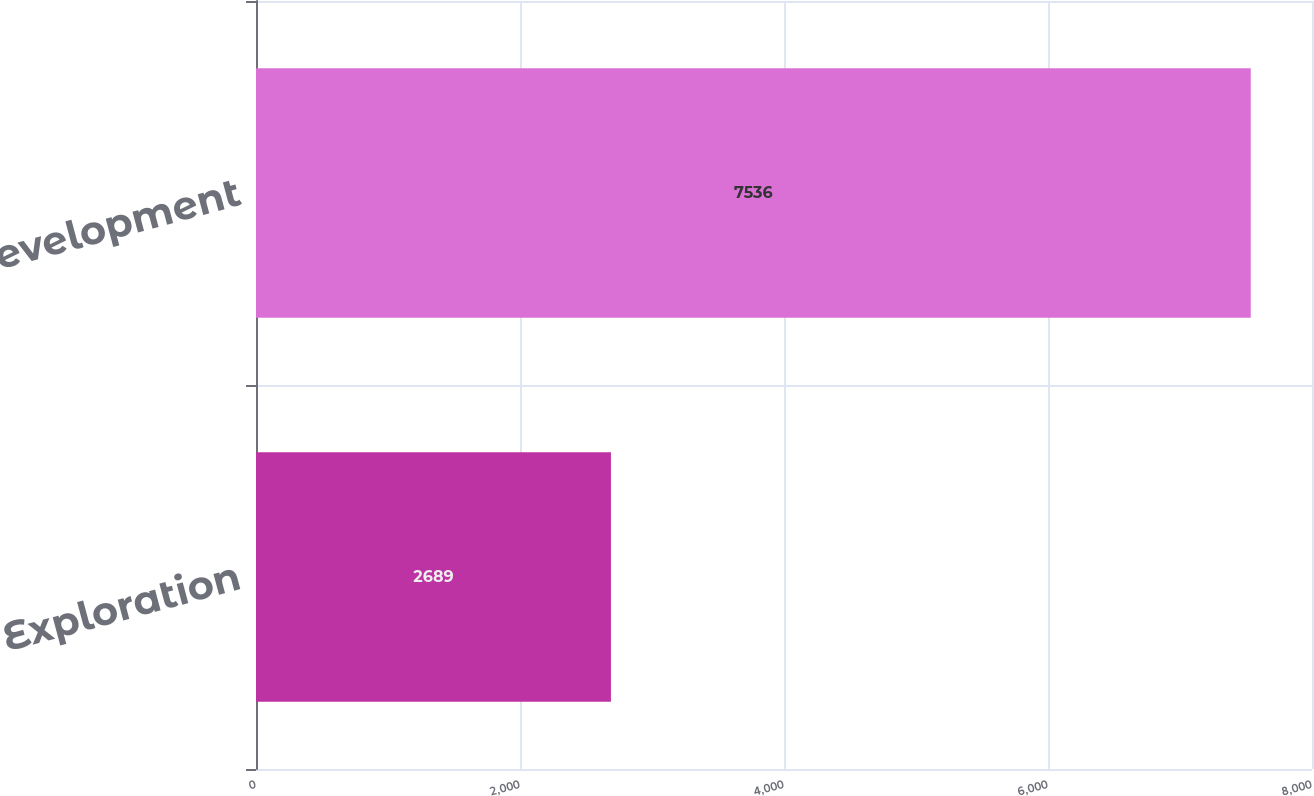Convert chart to OTSL. <chart><loc_0><loc_0><loc_500><loc_500><bar_chart><fcel>Exploration<fcel>Development<nl><fcel>2689<fcel>7536<nl></chart> 